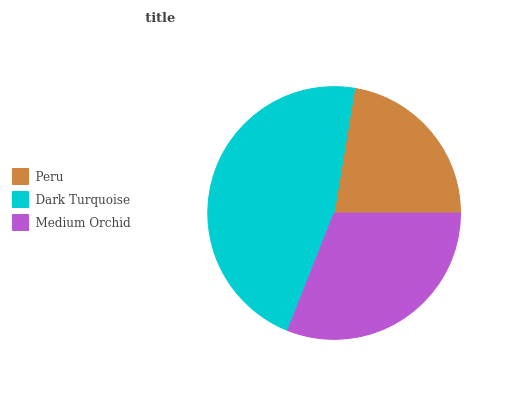Is Peru the minimum?
Answer yes or no. Yes. Is Dark Turquoise the maximum?
Answer yes or no. Yes. Is Medium Orchid the minimum?
Answer yes or no. No. Is Medium Orchid the maximum?
Answer yes or no. No. Is Dark Turquoise greater than Medium Orchid?
Answer yes or no. Yes. Is Medium Orchid less than Dark Turquoise?
Answer yes or no. Yes. Is Medium Orchid greater than Dark Turquoise?
Answer yes or no. No. Is Dark Turquoise less than Medium Orchid?
Answer yes or no. No. Is Medium Orchid the high median?
Answer yes or no. Yes. Is Medium Orchid the low median?
Answer yes or no. Yes. Is Dark Turquoise the high median?
Answer yes or no. No. Is Peru the low median?
Answer yes or no. No. 